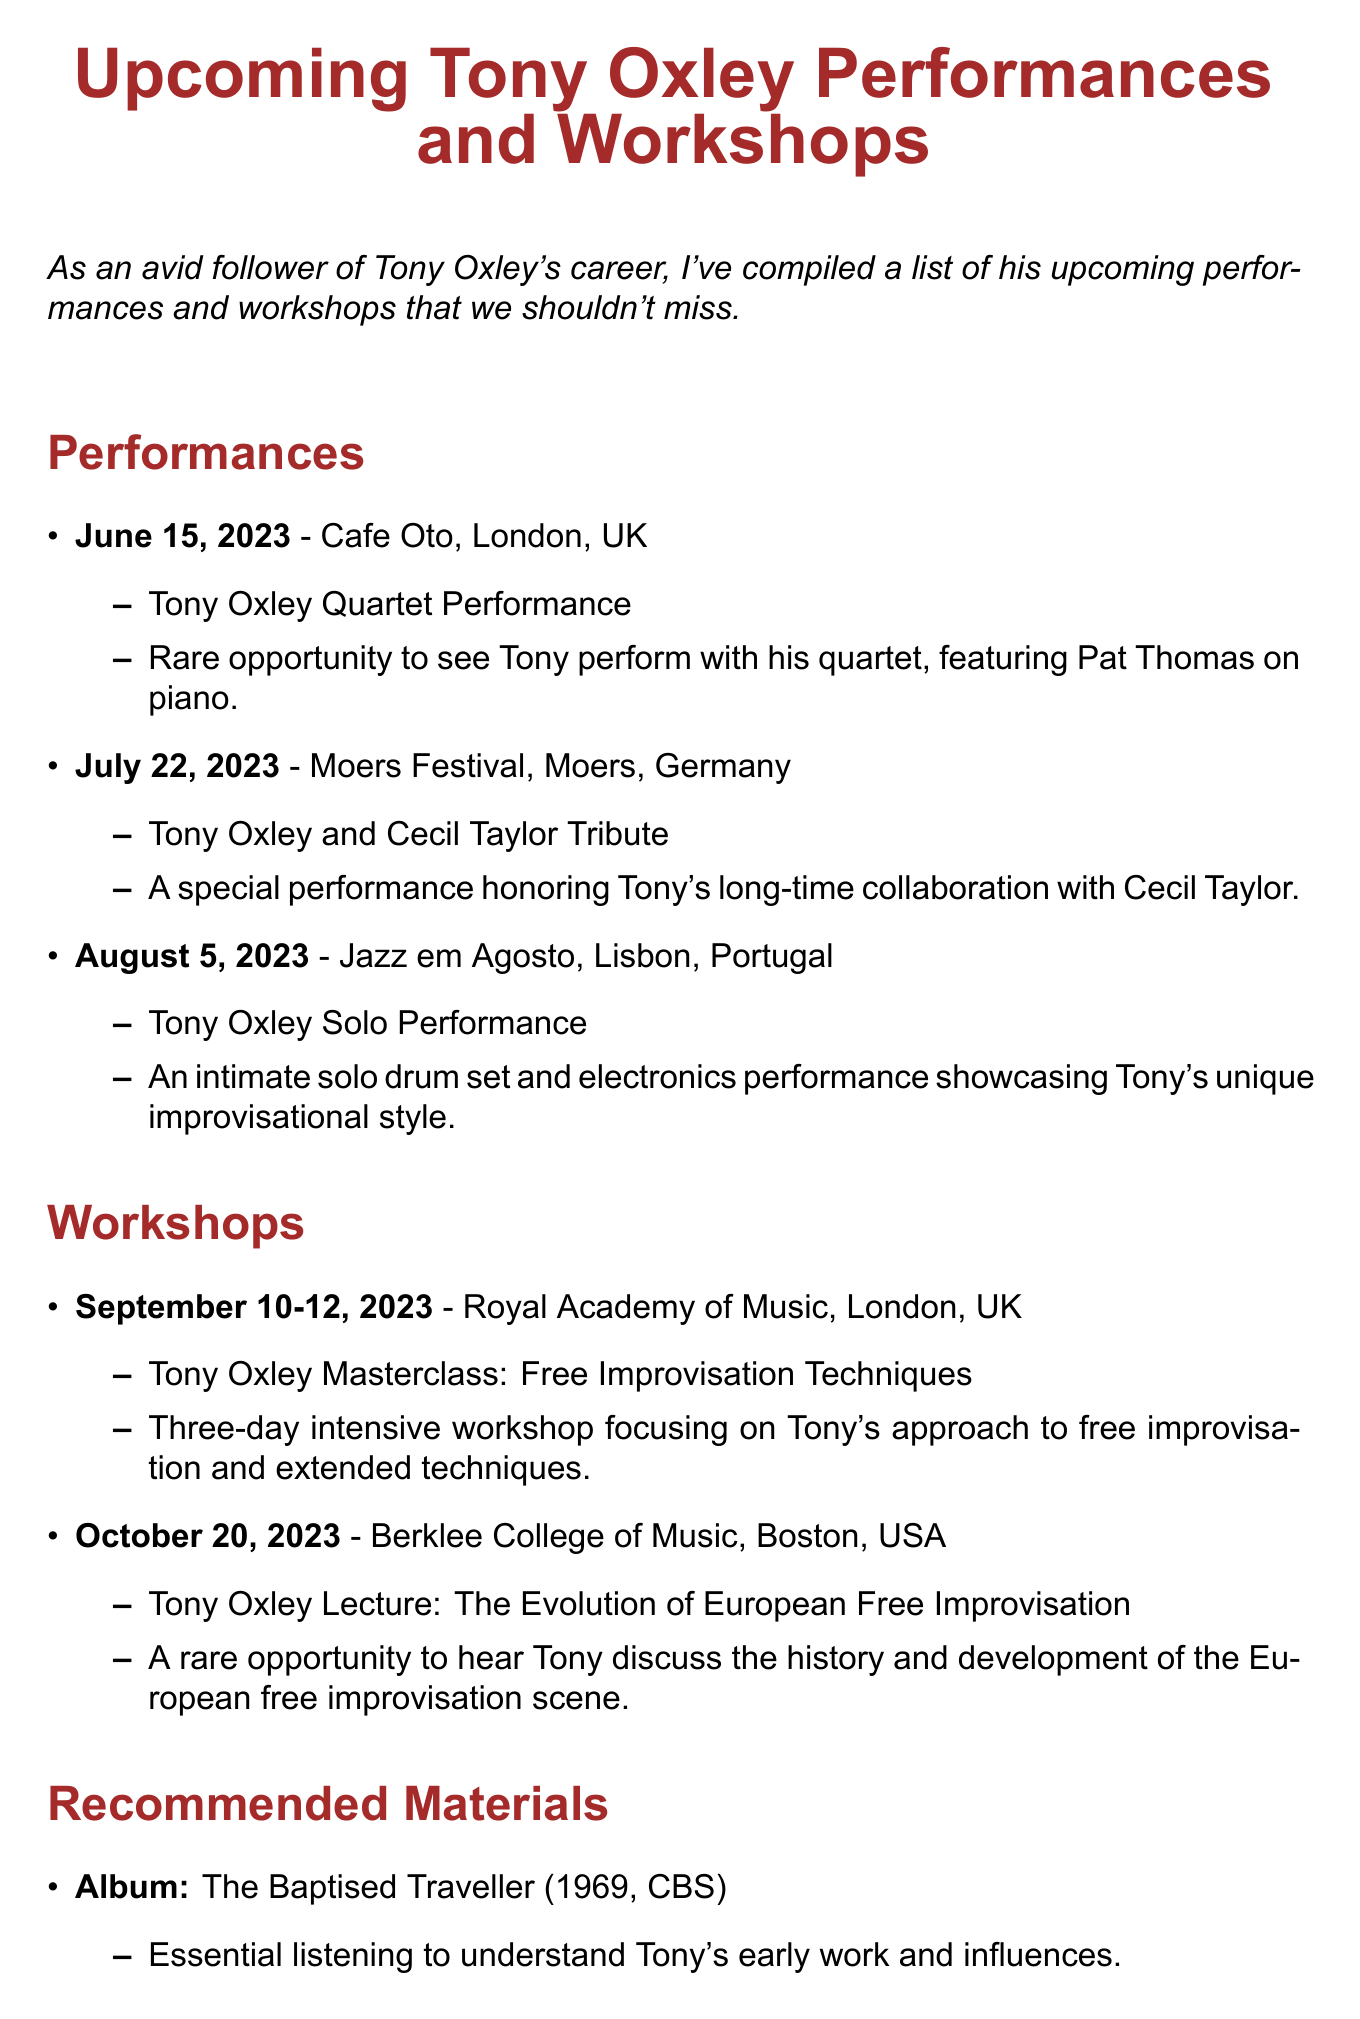What is the date of the Tony Oxley Quartet Performance? The date for this performance is mentioned in the section on performances.
Answer: June 15, 2023 Where will the Tony Oxley Masterclass be held? The venue for the masterclass is specified in the workshops section.
Answer: Royal Academy of Music What type of event is scheduled for October 20, 2023? The type of event is outlined in the workshops section for that date.
Answer: Lecture Who features in the Tony Oxley Quartet Performance? The document notes who is performing with Tony during this specific event.
Answer: Pat Thomas What city hosts the Jazz em Agosto event? The city for the Jazz em Agosto performance is listed with the event information.
Answer: Lisbon, Portugal How many days does the Tony Oxley Masterclass last? The duration of the masterclass is indicated in the workshops section.
Answer: Three days What is the title of the documentary about Tony Oxley? The documentary title is clearly mentioned in the recommended materials section.
Answer: Tony Oxley: The Advocate What genre does the album "The Baptised Traveller" represent? The context for understanding Tony's work and influences often relates to genre, which is implied in the recommended materials.
Answer: Jazz What is the main focus of the October 20, 2023 event? The main focus is described in the notes of the lecture event in the workshops section.
Answer: European Free Improvisation 